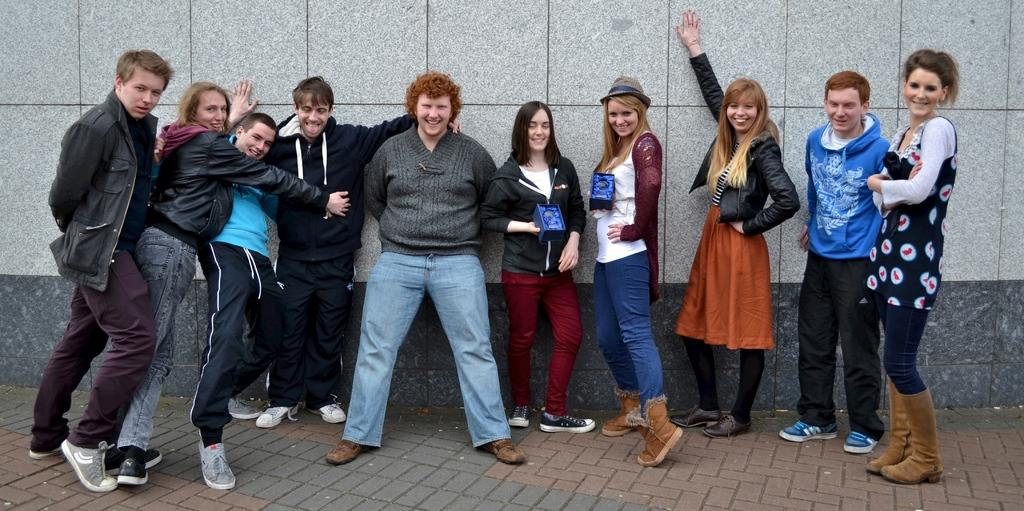What is the main subject of the image? The main subject of the image is the persons standing in the center. What can be seen in the background of the image? There is a wall in the background of the image. What is visible at the bottom of the image? There is a road visible at the bottom of the image. What flavor of pig can be seen in the image? There is no pig present in the image, and therefore no flavor can be determined. 